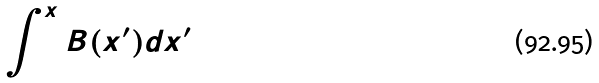<formula> <loc_0><loc_0><loc_500><loc_500>\int ^ { x } B ( x ^ { \prime } ) d x ^ { \prime }</formula> 